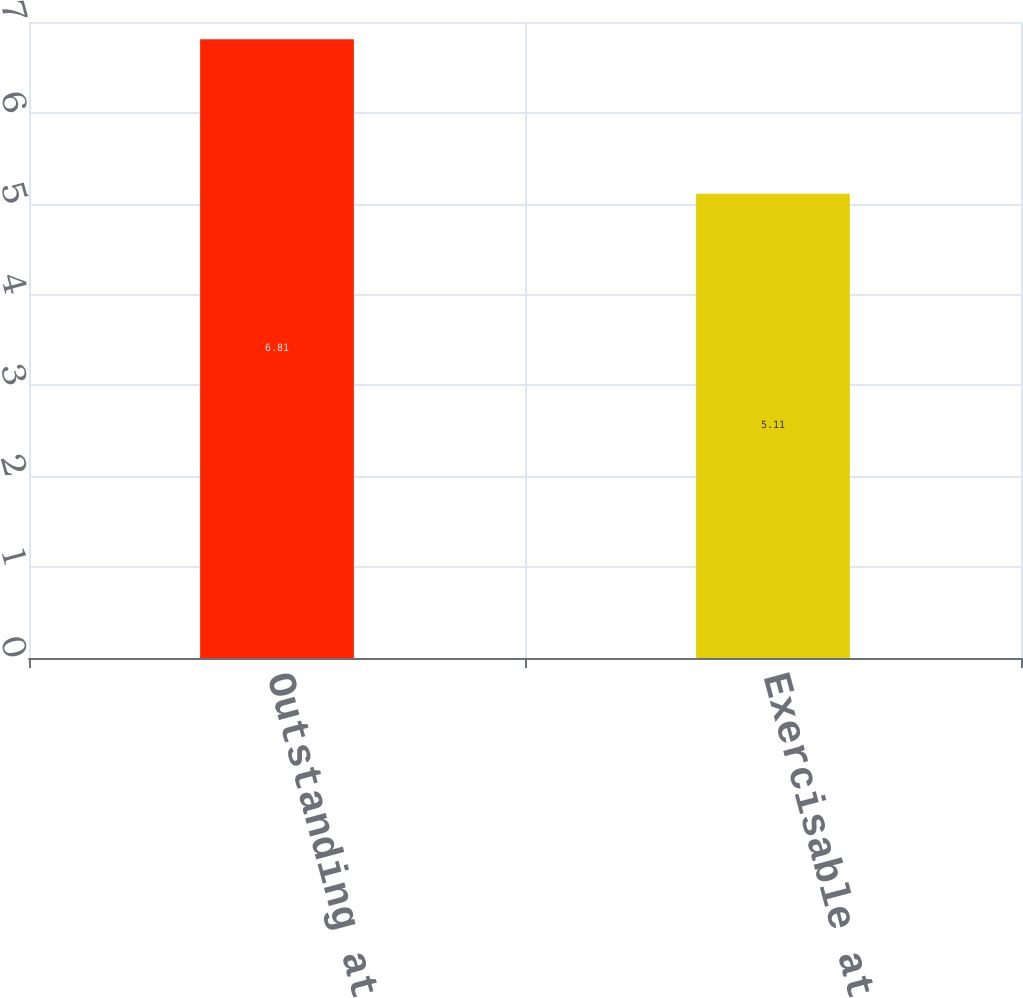Convert chart. <chart><loc_0><loc_0><loc_500><loc_500><bar_chart><fcel>Outstanding at end of year<fcel>Exercisable at end of year<nl><fcel>6.81<fcel>5.11<nl></chart> 